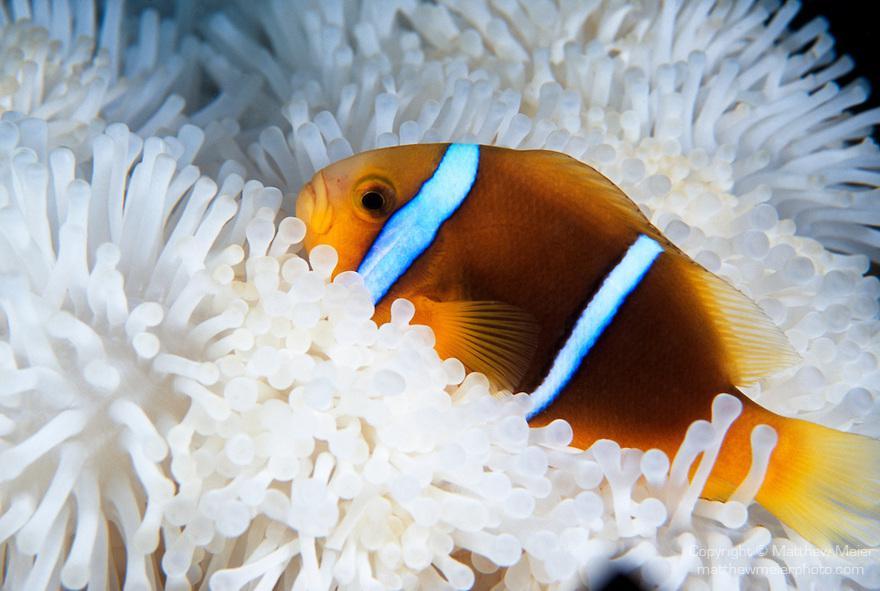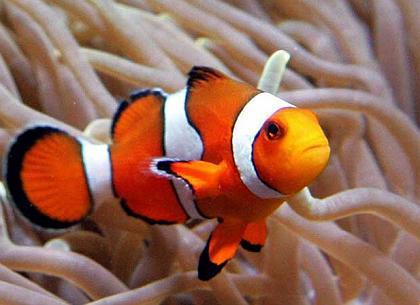The first image is the image on the left, the second image is the image on the right. For the images displayed, is the sentence "One image shows a clown fish facing fully forward and surrounded by nipple-like structures." factually correct? Answer yes or no. No. 